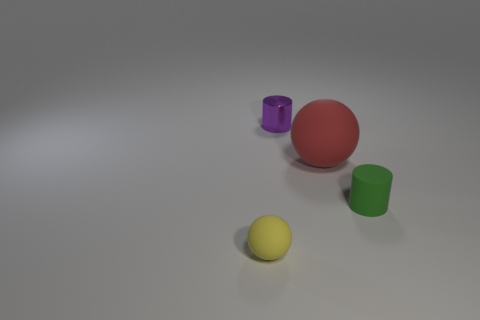Add 3 small green cylinders. How many objects exist? 7 Subtract all big yellow metal cylinders. Subtract all yellow matte things. How many objects are left? 3 Add 3 yellow rubber spheres. How many yellow rubber spheres are left? 4 Add 2 small gray objects. How many small gray objects exist? 2 Subtract 0 purple balls. How many objects are left? 4 